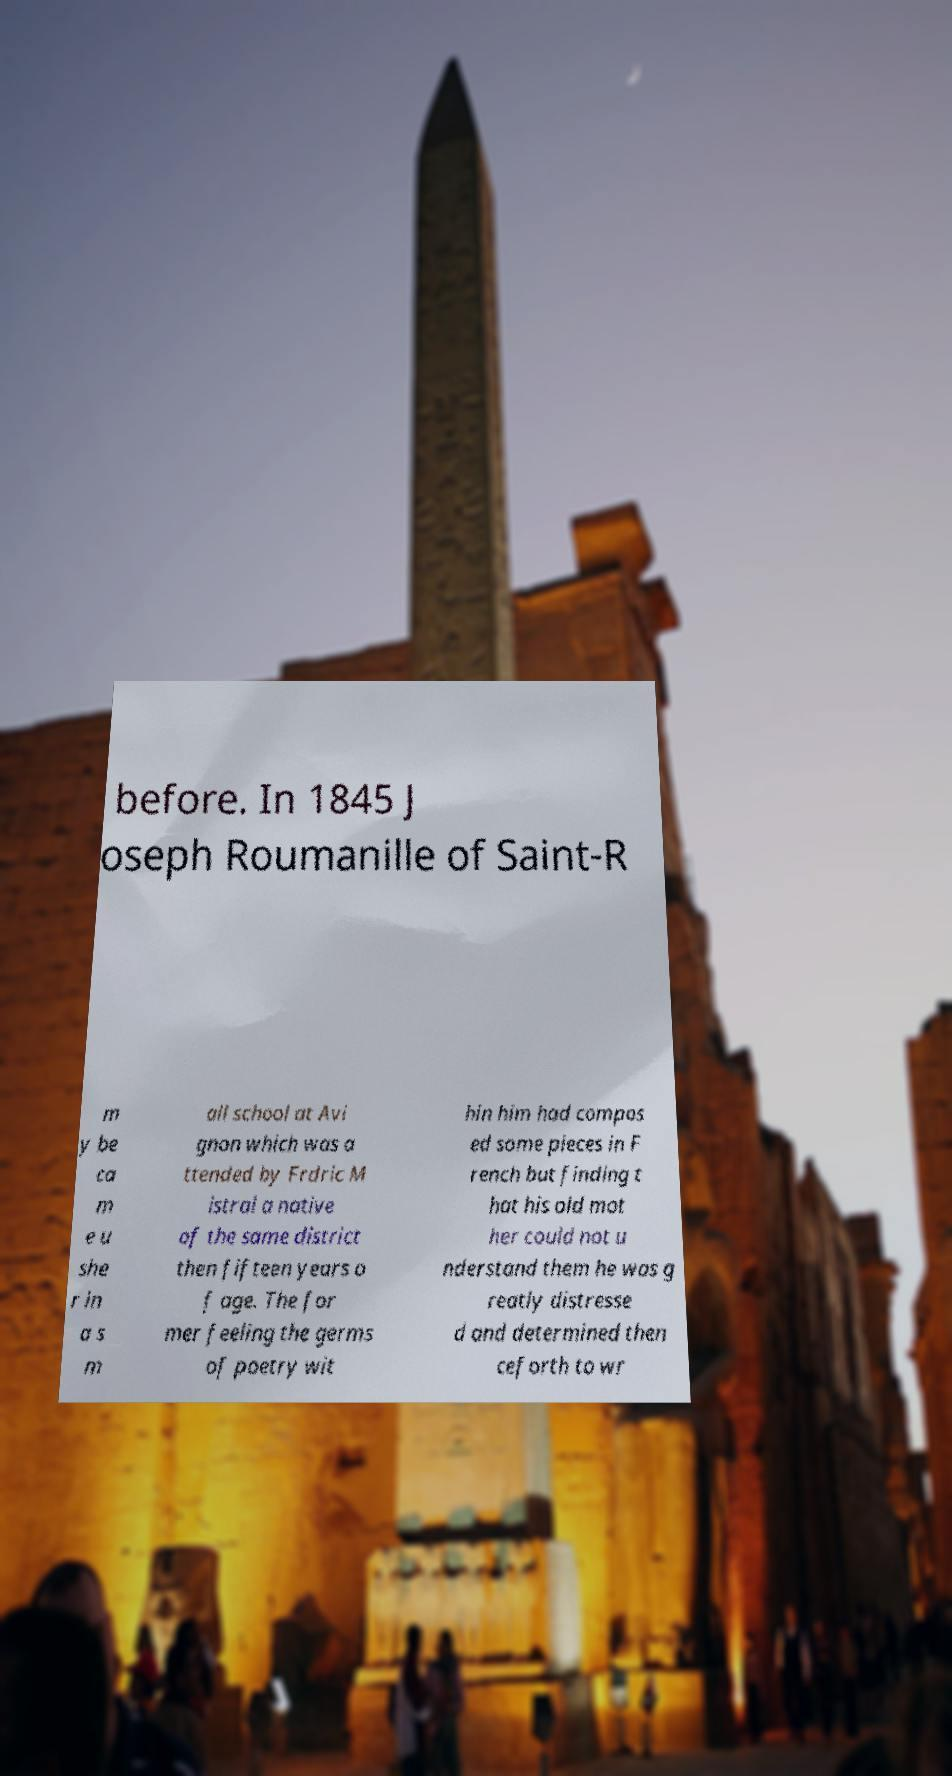For documentation purposes, I need the text within this image transcribed. Could you provide that? before. In 1845 J oseph Roumanille of Saint-R m y be ca m e u she r in a s m all school at Avi gnon which was a ttended by Frdric M istral a native of the same district then fifteen years o f age. The for mer feeling the germs of poetry wit hin him had compos ed some pieces in F rench but finding t hat his old mot her could not u nderstand them he was g reatly distresse d and determined then ceforth to wr 